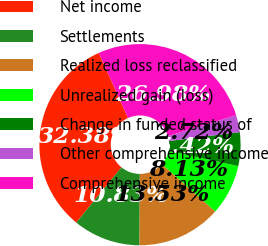Convert chart to OTSL. <chart><loc_0><loc_0><loc_500><loc_500><pie_chart><fcel>Net income<fcel>Settlements<fcel>Realized loss reclassified<fcel>Unrealized gain (loss)<fcel>Change in funded status of<fcel>Other comprehensive income<fcel>Comprehensive income<nl><fcel>32.38%<fcel>10.83%<fcel>13.53%<fcel>8.13%<fcel>5.42%<fcel>2.72%<fcel>26.98%<nl></chart> 